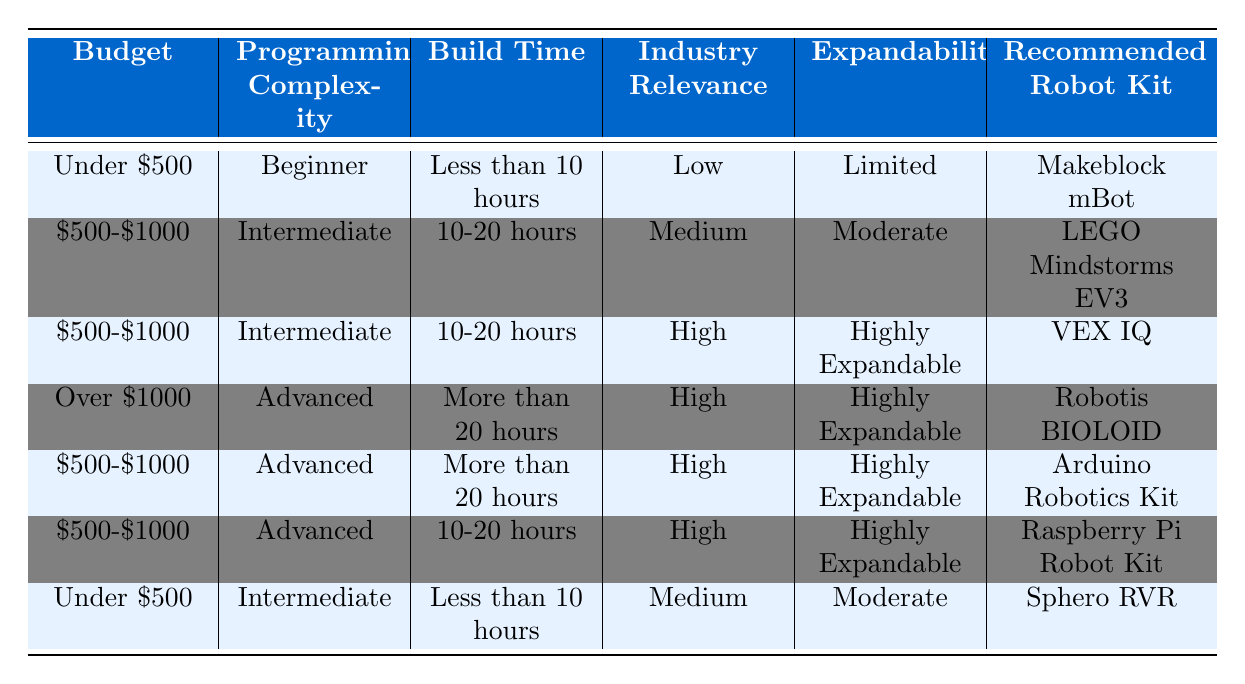What is the recommended robot kit for a budget under $500, with beginner programming complexity and less than 10 hours build time? From the table, under the conditions of a budget under $500, beginner programming complexity, and less than 10 hours build time, the recommended robot kit is "Makeblock mBot."
Answer: Makeblock mBot Which robot kit is recommended if the budget is between $500-$1000, the programming complexity is intermediate, the build time is between 10-20 hours, and industry relevance is high? In the table, there are two entries for the budget of $500-$1000 and intermediate programming complexity. One has medium industry relevance and the other has high industry relevance. The one with high industry relevance is "VEX IQ."
Answer: VEX IQ Is "Arduino Robotics Kit" suitable for a budget over $1000 with advanced programming complexity and more than 20 hours build time? In the table, "Arduino Robotics Kit" is listed under the budget range of $500-$1000, which does not meet the condition of a budget over $1000. Therefore, it is not suitable.
Answer: No What are the total options for programming complexity listed in the table? The table lists three options for programming complexity: Beginner, Intermediate, and Advanced. Counting these gives a total of 3 options.
Answer: 3 If we consider only the robot kits with high industry relevance, how many such kits are there in the table? The table shows three kits with high industry relevance: "VEX IQ," "Robotis BIOLOID," and "Arduino Robotics Kit." Therefore, there are three kits that meet this criterion.
Answer: 3 What is the recommended robot kit if the budget is under $500, the programming complexity is intermediate, and the build time is less than 10 hours? The table shows that under these criteria, the recommended robot kit is "Sphero RVR."
Answer: Sphero RVR Is the "Robotis BIOLOID" considered highly expandable? The table indicates that "Robotis BIOLOID" has the characteristic of being highly expandable. Thus, it is considered highly expandable.
Answer: Yes Which robot kit has the longest build time requirement and what is that time? The kit with the longest build time requirement is "Robotis BIOLOID," which specifies a build time of more than 20 hours.
Answer: More than 20 hours 